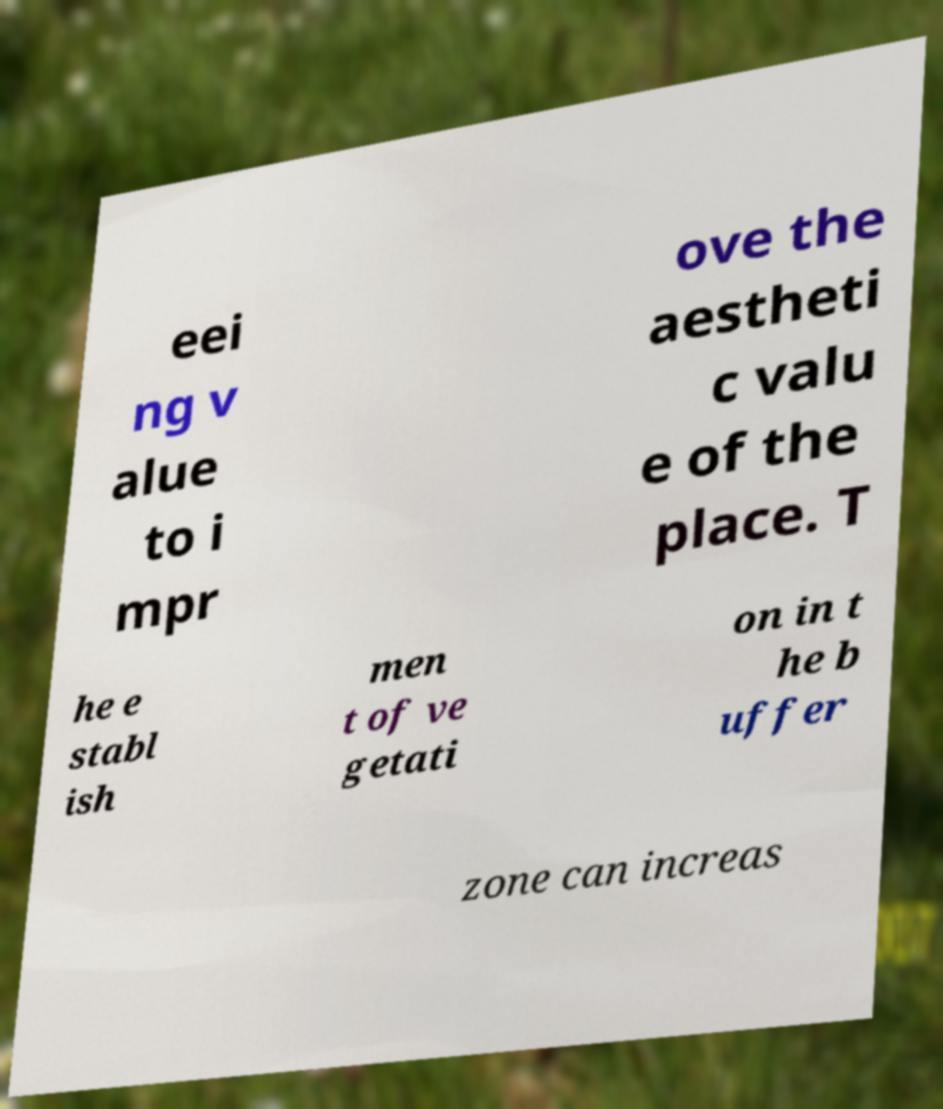Please identify and transcribe the text found in this image. eei ng v alue to i mpr ove the aestheti c valu e of the place. T he e stabl ish men t of ve getati on in t he b uffer zone can increas 